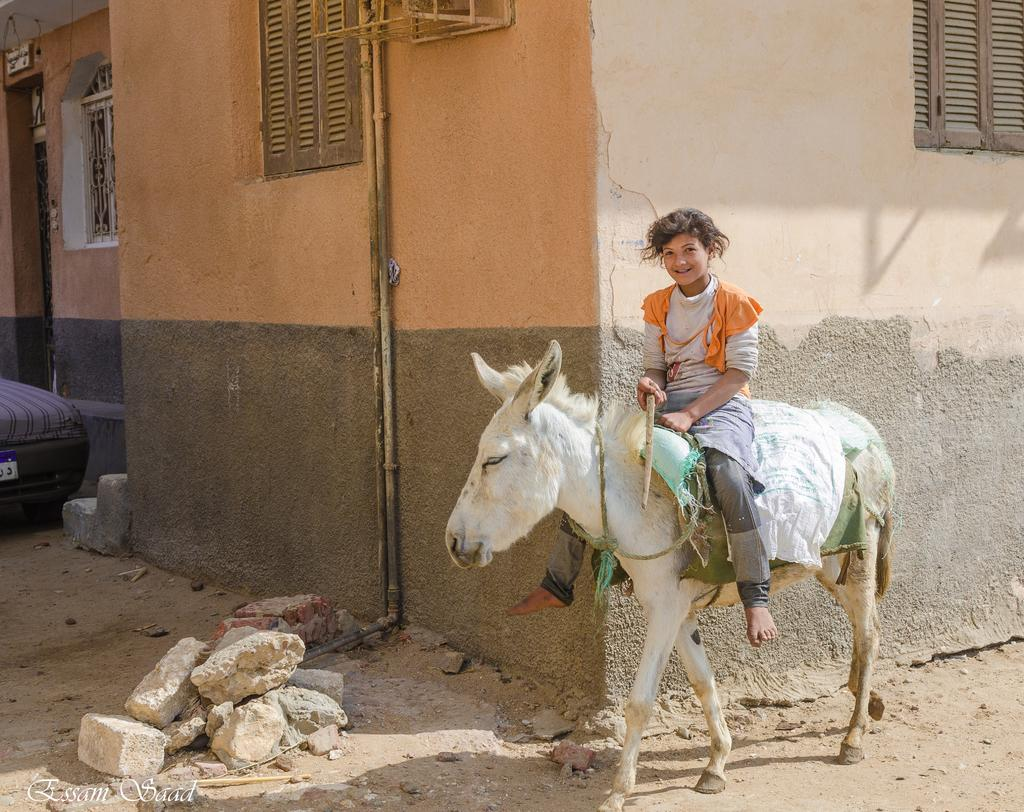What is the person in the image doing? There is a person sitting on a donkey in the image. What type of surface can be seen in the image? There are stones visible in the image. What mode of transportation is present in the image? There is a vehicle in the image. What can be seen in the background of the image? There are windows and a wall in the background of the image. What type of suit is the wind wearing in the image? There is no wind or suit present in the image. How does the air affect the person sitting on the donkey in the image? The air does not affect the person sitting on the donkey in the image; there is no indication of wind or any other weather conditions. 